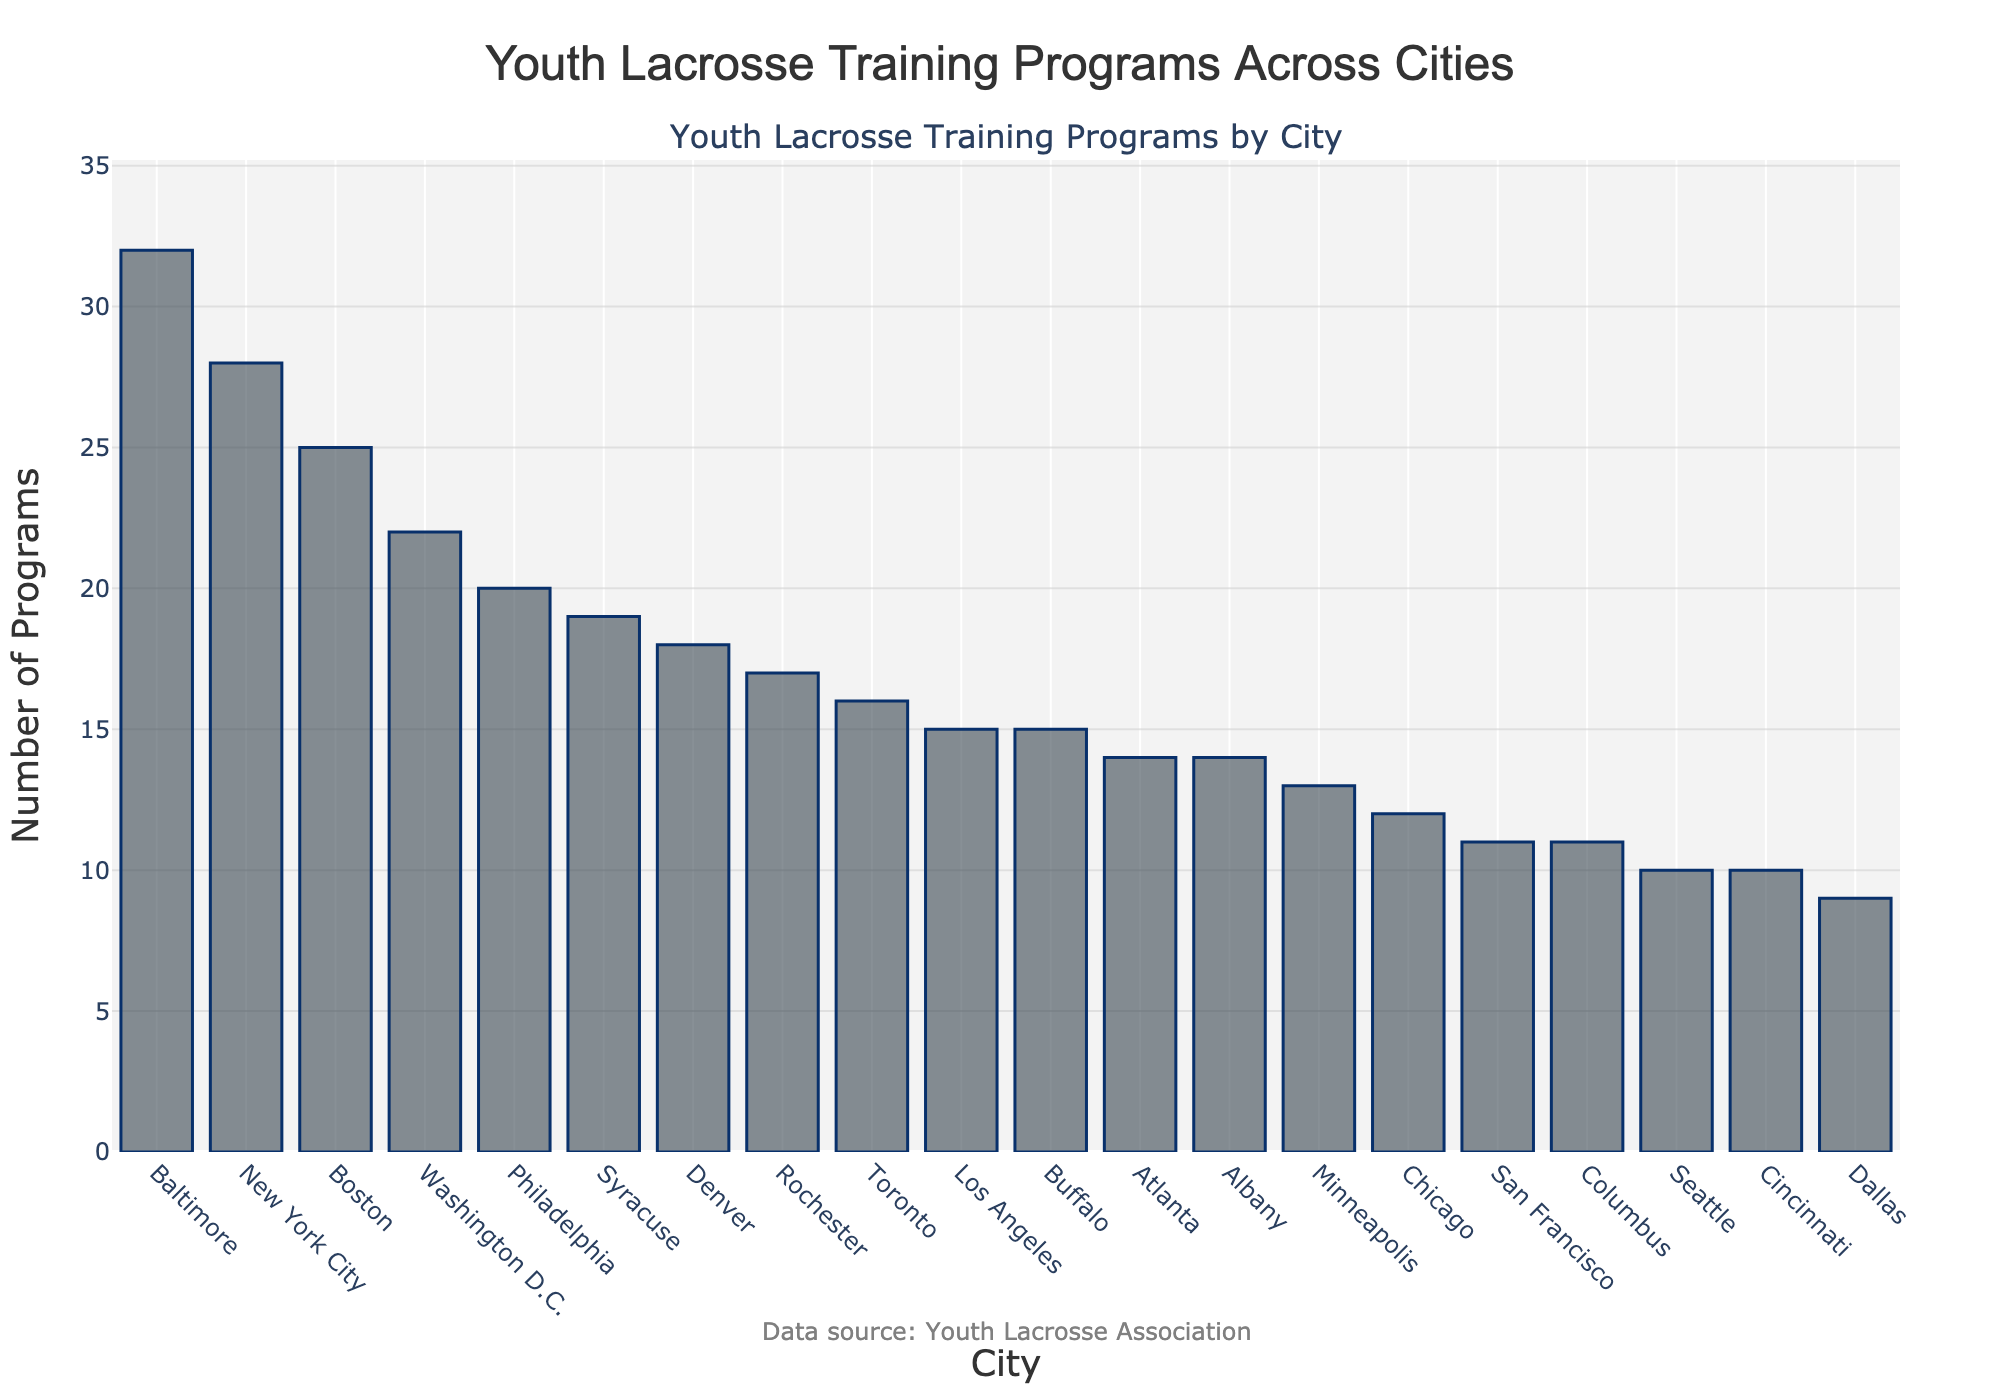What's the city with the highest number of youth lacrosse training programs? The highest bar on the plot represents this city, and it is labeled at the bottom.
Answer: Baltimore Which city has more youth lacrosse training programs, Denver or Atlanta? Compare the heights of the bars for Denver and Atlanta. Denver's bar is higher than Atlanta's.
Answer: Denver What is the total number of youth lacrosse training programs available in New York City, Los Angeles, and Chicago? Sum the numbers for the three cities from the plot: New York City (28), Los Angeles (15), and Chicago (12). 28 + 15 + 12 = 55
Answer: 55 Which two cities have the same number of youth lacrosse training programs? Find bars that are of equal height and verify their labels. Los Angeles and Buffalo both have 15 programs.
Answer: Los Angeles and Buffalo What's the average number of youth lacrosse training programs across all cities? Add the number of programs for all cities and divide by the total number of cities. The sum is 330 and there are 20 cities. 330 / 20 = 16.5
Answer: 16.5 Is the number of youth lacrosse training programs in Philadelphia greater than in Toronto? Compare the heights of the bars for Philadelphia and Toronto. Philadelphia's bar is higher.
Answer: Yes What is the difference in the number of programs between Washington D.C. and San Francisco? Look at the heights of their bars. Washington D.C. has 22 and San Francisco has 11. Calculate the difference: 22 - 11 = 11
Answer: 11 Which city has the lowest number of youth lacrosse training programs? The shortest bar represents this city, and it is labeled at the bottom.
Answer: Dallas How many more programs does Boston have compared to Chicago? Look at the heights of their bars. Boston has 25 and Chicago has 12. Calculate the difference: 25 - 12 = 13
Answer: 13 Are there more youth lacrosse training programs in Dallas or Albany? Compare the heights of the bars for Dallas and Albany. Albany's bar is higher than Dallas's.
Answer: Albany 